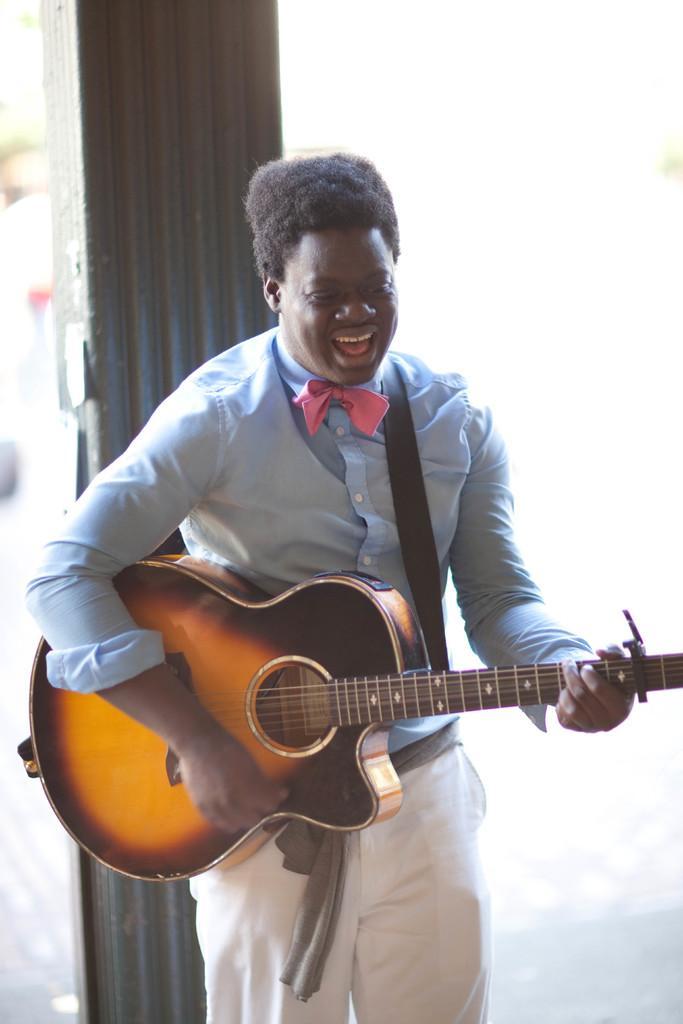In one or two sentences, can you explain what this image depicts? In this image I can see a person standing and smiling and he is playing the musical instrument. 